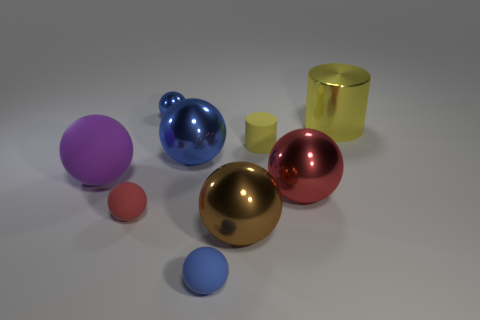Subtract all cyan blocks. How many blue balls are left? 3 Subtract all blue balls. How many balls are left? 4 Subtract all small rubber balls. How many balls are left? 5 Subtract 3 balls. How many balls are left? 4 Subtract all green spheres. Subtract all purple cylinders. How many spheres are left? 7 Add 1 blue matte spheres. How many objects exist? 10 Subtract all spheres. How many objects are left? 2 Add 5 small metal things. How many small metal things exist? 6 Subtract 0 brown cubes. How many objects are left? 9 Subtract all tiny red spheres. Subtract all blue shiny spheres. How many objects are left? 6 